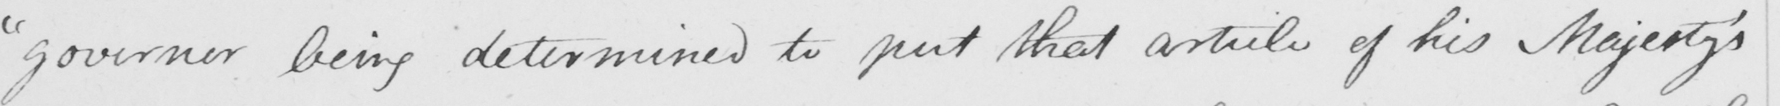Please transcribe the handwritten text in this image. " governor being determined to put that article of his Majesty ' s 